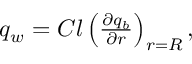Convert formula to latex. <formula><loc_0><loc_0><loc_500><loc_500>\begin{array} { r } { q _ { w } = C l \left ( \frac { \partial q _ { b } } { \partial r } \right ) _ { r = R } , } \end{array}</formula> 